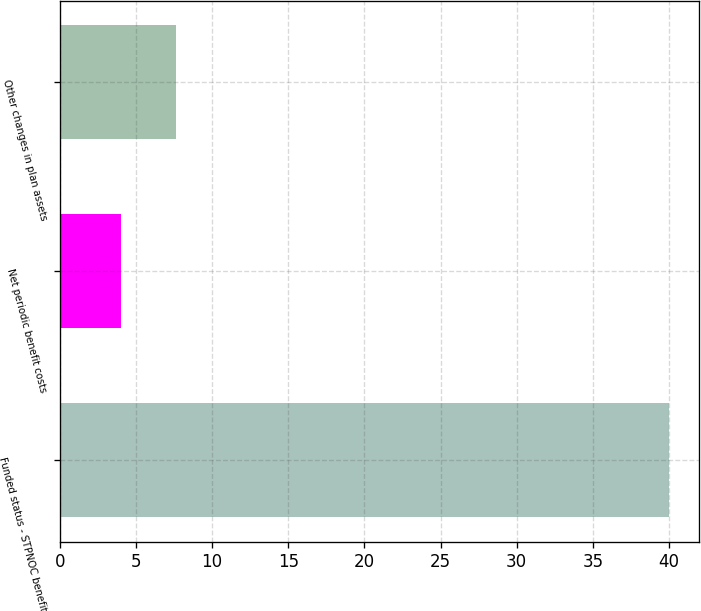<chart> <loc_0><loc_0><loc_500><loc_500><bar_chart><fcel>Funded status - STPNOC benefit<fcel>Net periodic benefit costs<fcel>Other changes in plan assets<nl><fcel>40<fcel>4<fcel>7.6<nl></chart> 